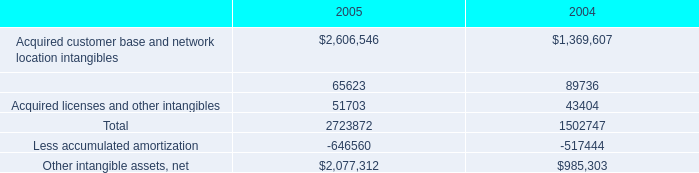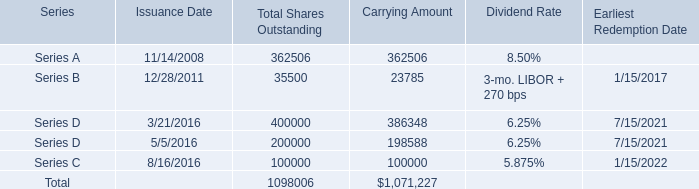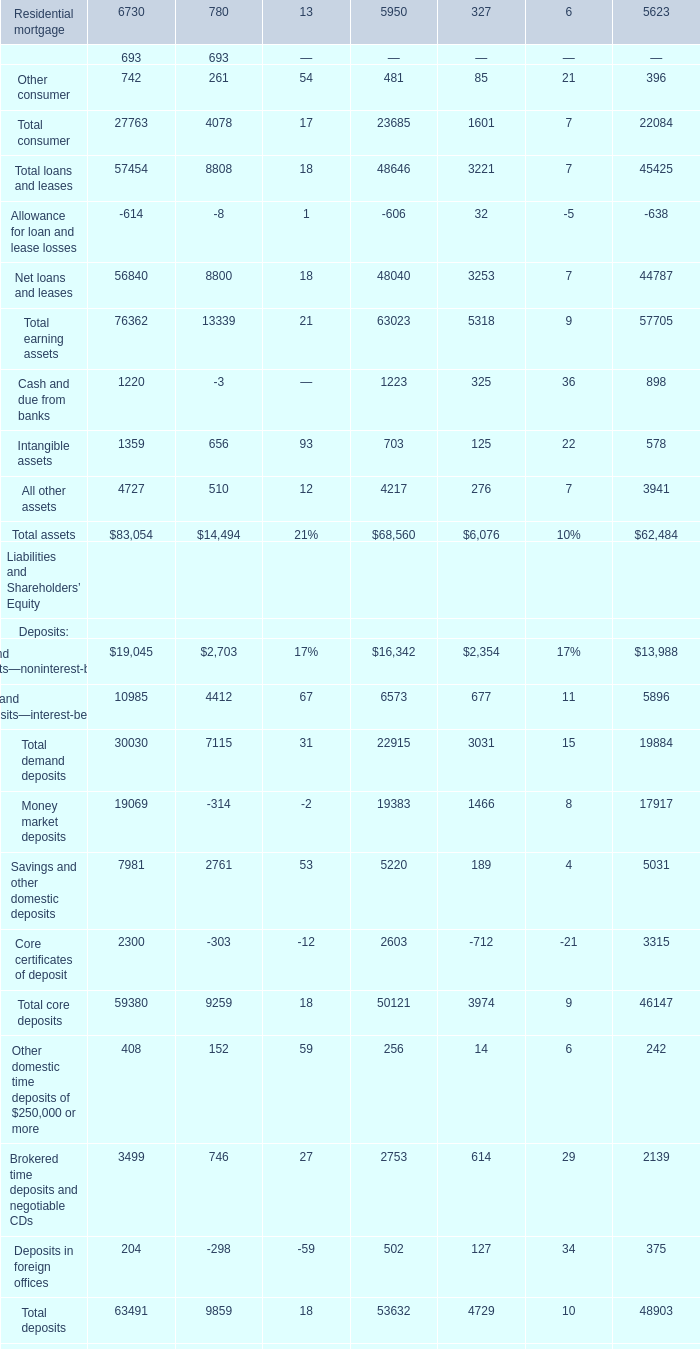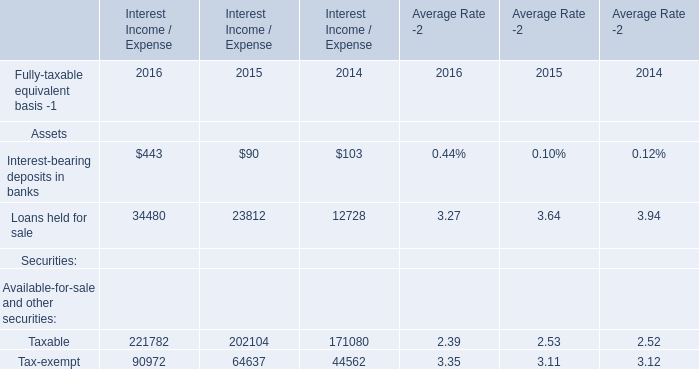In the year with the most Loans held for sale, what is the growth rate of interest-bearing deposits in banks? (in %) 
Computations: ((443 - 90) / 90)
Answer: 3.92222. 